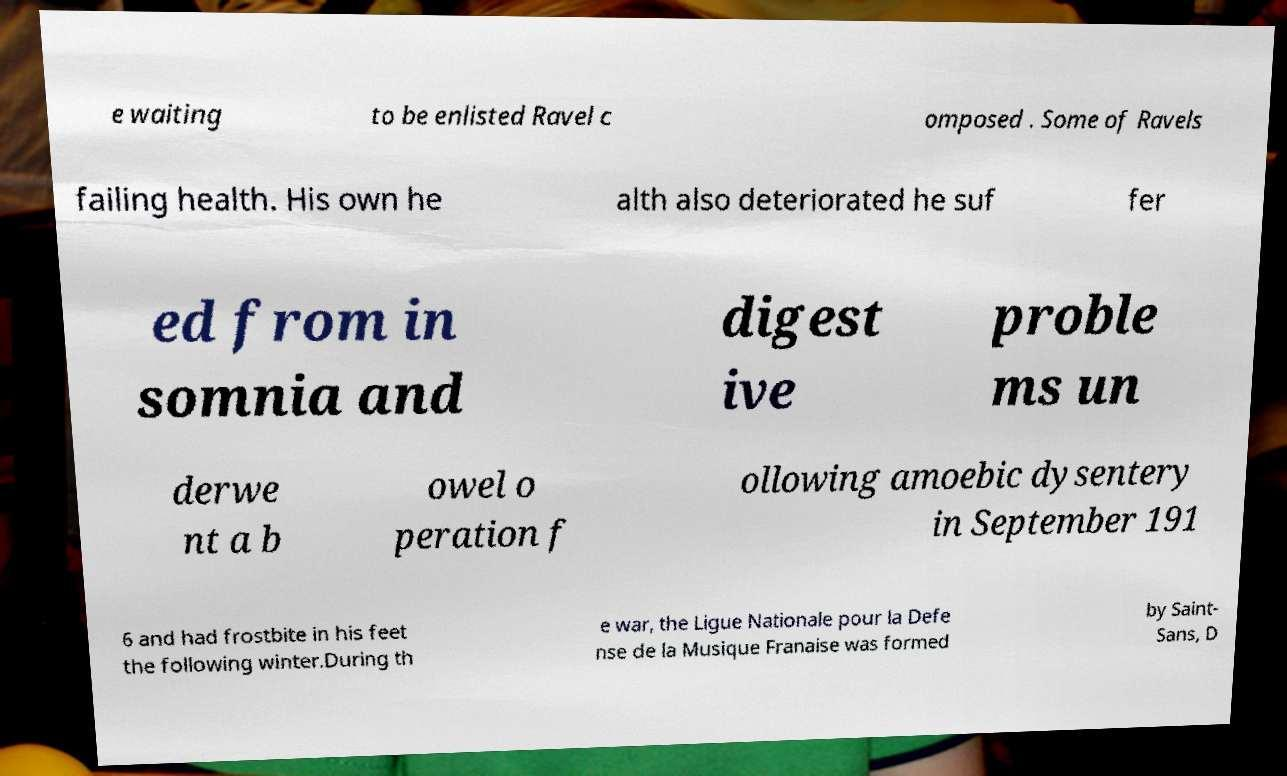Could you assist in decoding the text presented in this image and type it out clearly? e waiting to be enlisted Ravel c omposed . Some of Ravels failing health. His own he alth also deteriorated he suf fer ed from in somnia and digest ive proble ms un derwe nt a b owel o peration f ollowing amoebic dysentery in September 191 6 and had frostbite in his feet the following winter.During th e war, the Ligue Nationale pour la Defe nse de la Musique Franaise was formed by Saint- Sans, D 